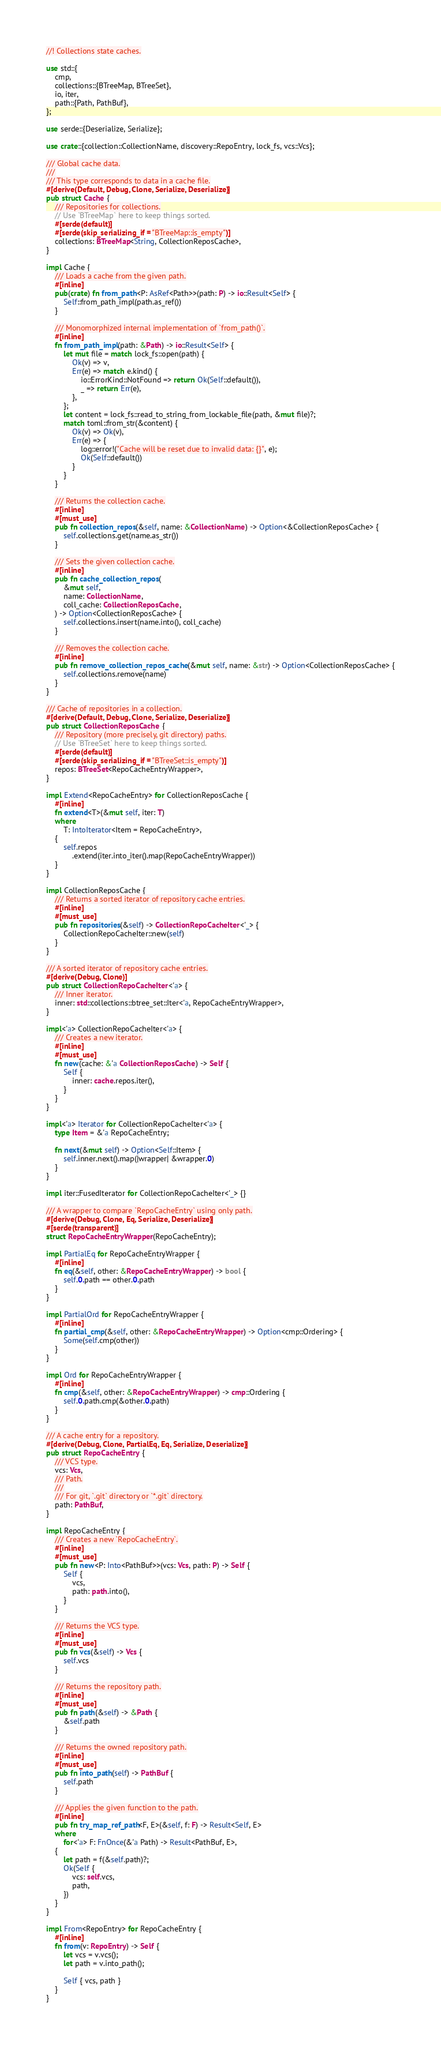<code> <loc_0><loc_0><loc_500><loc_500><_Rust_>//! Collections state caches.

use std::{
    cmp,
    collections::{BTreeMap, BTreeSet},
    io, iter,
    path::{Path, PathBuf},
};

use serde::{Deserialize, Serialize};

use crate::{collection::CollectionName, discovery::RepoEntry, lock_fs, vcs::Vcs};

/// Global cache data.
///
/// This type corresponds to data in a cache file.
#[derive(Default, Debug, Clone, Serialize, Deserialize)]
pub struct Cache {
    /// Repositories for collections.
    // Use `BTreeMap` here to keep things sorted.
    #[serde(default)]
    #[serde(skip_serializing_if = "BTreeMap::is_empty")]
    collections: BTreeMap<String, CollectionReposCache>,
}

impl Cache {
    /// Loads a cache from the given path.
    #[inline]
    pub(crate) fn from_path<P: AsRef<Path>>(path: P) -> io::Result<Self> {
        Self::from_path_impl(path.as_ref())
    }

    /// Monomorphized internal implementation of `from_path()`.
    #[inline]
    fn from_path_impl(path: &Path) -> io::Result<Self> {
        let mut file = match lock_fs::open(path) {
            Ok(v) => v,
            Err(e) => match e.kind() {
                io::ErrorKind::NotFound => return Ok(Self::default()),
                _ => return Err(e),
            },
        };
        let content = lock_fs::read_to_string_from_lockable_file(path, &mut file)?;
        match toml::from_str(&content) {
            Ok(v) => Ok(v),
            Err(e) => {
                log::error!("Cache will be reset due to invalid data: {}", e);
                Ok(Self::default())
            }
        }
    }

    /// Returns the collection cache.
    #[inline]
    #[must_use]
    pub fn collection_repos(&self, name: &CollectionName) -> Option<&CollectionReposCache> {
        self.collections.get(name.as_str())
    }

    /// Sets the given collection cache.
    #[inline]
    pub fn cache_collection_repos(
        &mut self,
        name: CollectionName,
        coll_cache: CollectionReposCache,
    ) -> Option<CollectionReposCache> {
        self.collections.insert(name.into(), coll_cache)
    }

    /// Removes the collection cache.
    #[inline]
    pub fn remove_collection_repos_cache(&mut self, name: &str) -> Option<CollectionReposCache> {
        self.collections.remove(name)
    }
}

/// Cache of repositories in a collection.
#[derive(Default, Debug, Clone, Serialize, Deserialize)]
pub struct CollectionReposCache {
    /// Repository (more precisely, git directory) paths.
    // Use `BTreeSet` here to keep things sorted.
    #[serde(default)]
    #[serde(skip_serializing_if = "BTreeSet::is_empty")]
    repos: BTreeSet<RepoCacheEntryWrapper>,
}

impl Extend<RepoCacheEntry> for CollectionReposCache {
    #[inline]
    fn extend<T>(&mut self, iter: T)
    where
        T: IntoIterator<Item = RepoCacheEntry>,
    {
        self.repos
            .extend(iter.into_iter().map(RepoCacheEntryWrapper))
    }
}

impl CollectionReposCache {
    /// Returns a sorted iterator of repository cache entries.
    #[inline]
    #[must_use]
    pub fn repositories(&self) -> CollectionRepoCacheIter<'_> {
        CollectionRepoCacheIter::new(self)
    }
}

/// A sorted iterator of repository cache entries.
#[derive(Debug, Clone)]
pub struct CollectionRepoCacheIter<'a> {
    /// Inner iterator.
    inner: std::collections::btree_set::Iter<'a, RepoCacheEntryWrapper>,
}

impl<'a> CollectionRepoCacheIter<'a> {
    /// Creates a new iterator.
    #[inline]
    #[must_use]
    fn new(cache: &'a CollectionReposCache) -> Self {
        Self {
            inner: cache.repos.iter(),
        }
    }
}

impl<'a> Iterator for CollectionRepoCacheIter<'a> {
    type Item = &'a RepoCacheEntry;

    fn next(&mut self) -> Option<Self::Item> {
        self.inner.next().map(|wrapper| &wrapper.0)
    }
}

impl iter::FusedIterator for CollectionRepoCacheIter<'_> {}

/// A wrapper to compare `RepoCacheEntry` using only path.
#[derive(Debug, Clone, Eq, Serialize, Deserialize)]
#[serde(transparent)]
struct RepoCacheEntryWrapper(RepoCacheEntry);

impl PartialEq for RepoCacheEntryWrapper {
    #[inline]
    fn eq(&self, other: &RepoCacheEntryWrapper) -> bool {
        self.0.path == other.0.path
    }
}

impl PartialOrd for RepoCacheEntryWrapper {
    #[inline]
    fn partial_cmp(&self, other: &RepoCacheEntryWrapper) -> Option<cmp::Ordering> {
        Some(self.cmp(other))
    }
}

impl Ord for RepoCacheEntryWrapper {
    #[inline]
    fn cmp(&self, other: &RepoCacheEntryWrapper) -> cmp::Ordering {
        self.0.path.cmp(&other.0.path)
    }
}

/// A cache entry for a repository.
#[derive(Debug, Clone, PartialEq, Eq, Serialize, Deserialize)]
pub struct RepoCacheEntry {
    /// VCS type.
    vcs: Vcs,
    /// Path.
    ///
    /// For git, `.git` directory or `*.git` directory.
    path: PathBuf,
}

impl RepoCacheEntry {
    /// Creates a new `RepoCacheEntry`.
    #[inline]
    #[must_use]
    pub fn new<P: Into<PathBuf>>(vcs: Vcs, path: P) -> Self {
        Self {
            vcs,
            path: path.into(),
        }
    }

    /// Returns the VCS type.
    #[inline]
    #[must_use]
    pub fn vcs(&self) -> Vcs {
        self.vcs
    }

    /// Returns the repository path.
    #[inline]
    #[must_use]
    pub fn path(&self) -> &Path {
        &self.path
    }

    /// Returns the owned repository path.
    #[inline]
    #[must_use]
    pub fn into_path(self) -> PathBuf {
        self.path
    }

    /// Applies the given function to the path.
    #[inline]
    pub fn try_map_ref_path<F, E>(&self, f: F) -> Result<Self, E>
    where
        for<'a> F: FnOnce(&'a Path) -> Result<PathBuf, E>,
    {
        let path = f(&self.path)?;
        Ok(Self {
            vcs: self.vcs,
            path,
        })
    }
}

impl From<RepoEntry> for RepoCacheEntry {
    #[inline]
    fn from(v: RepoEntry) -> Self {
        let vcs = v.vcs();
        let path = v.into_path();

        Self { vcs, path }
    }
}
</code> 